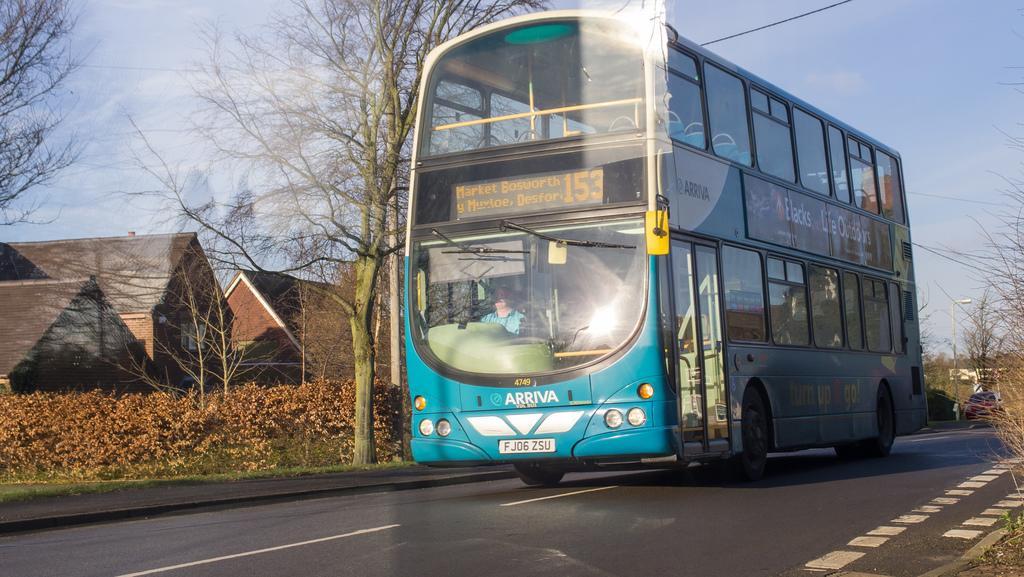Please provide a concise description of this image. In this picture we can observe a double decker bus on the road which is in blue color. We can observe a LED display on the bus. On the left side of the road there are some plants and houses. We can observe trees. In the background there is a sky. 